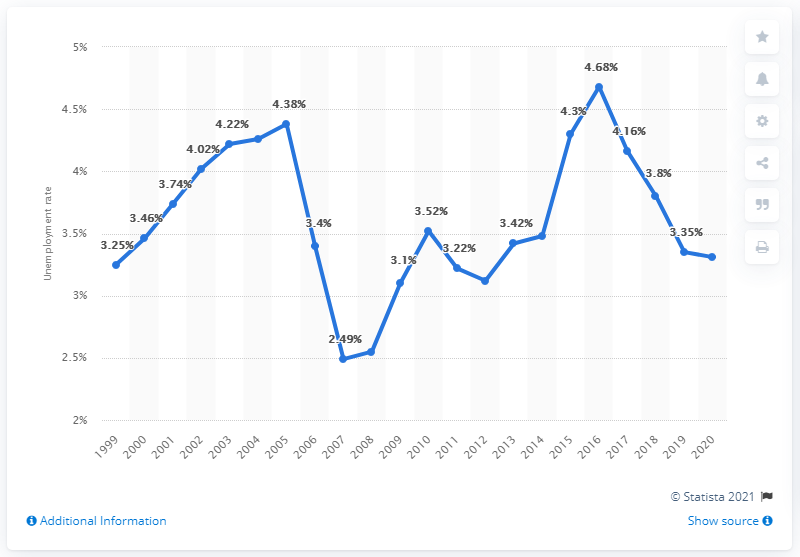What was the unemployment rate in Norway in 2020? According to the provided graph, the unemployment rate in Norway for the year 2020 was 5.4%. This reflects an increase compared to the previous years, which could be attributed to impacts from the global health events and economic challenges of that time. 